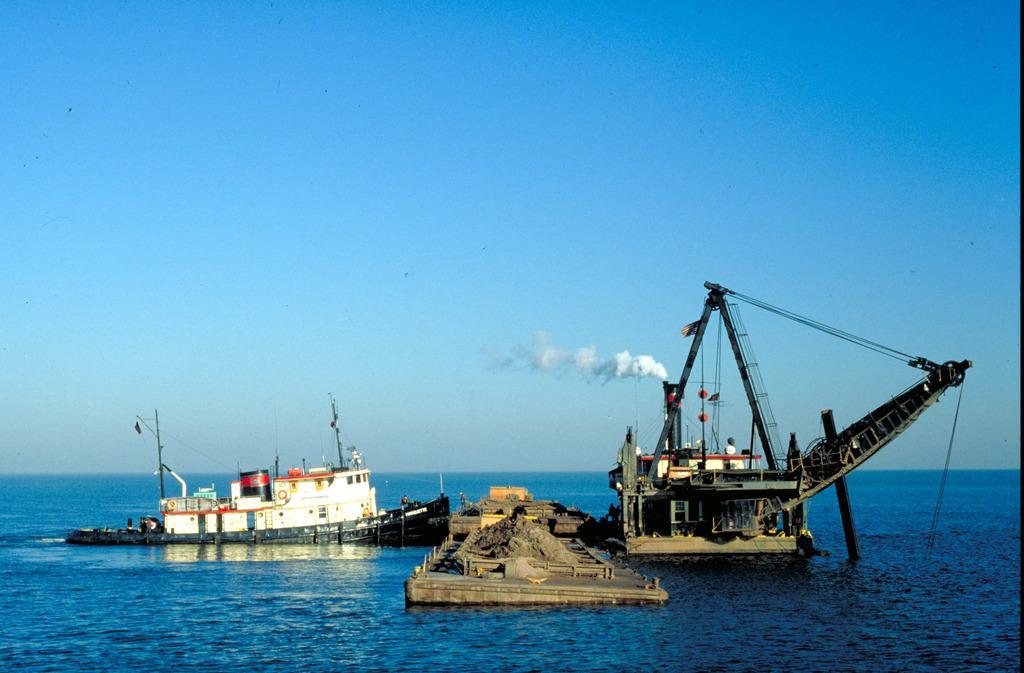Could you give a brief overview of what you see in this image? In this image I can see the sea, on which there are two ships and there is fume come out from one of the ship, there is a bridge in the middle, on which there is a soil, boxes, at the top there is the sky. 